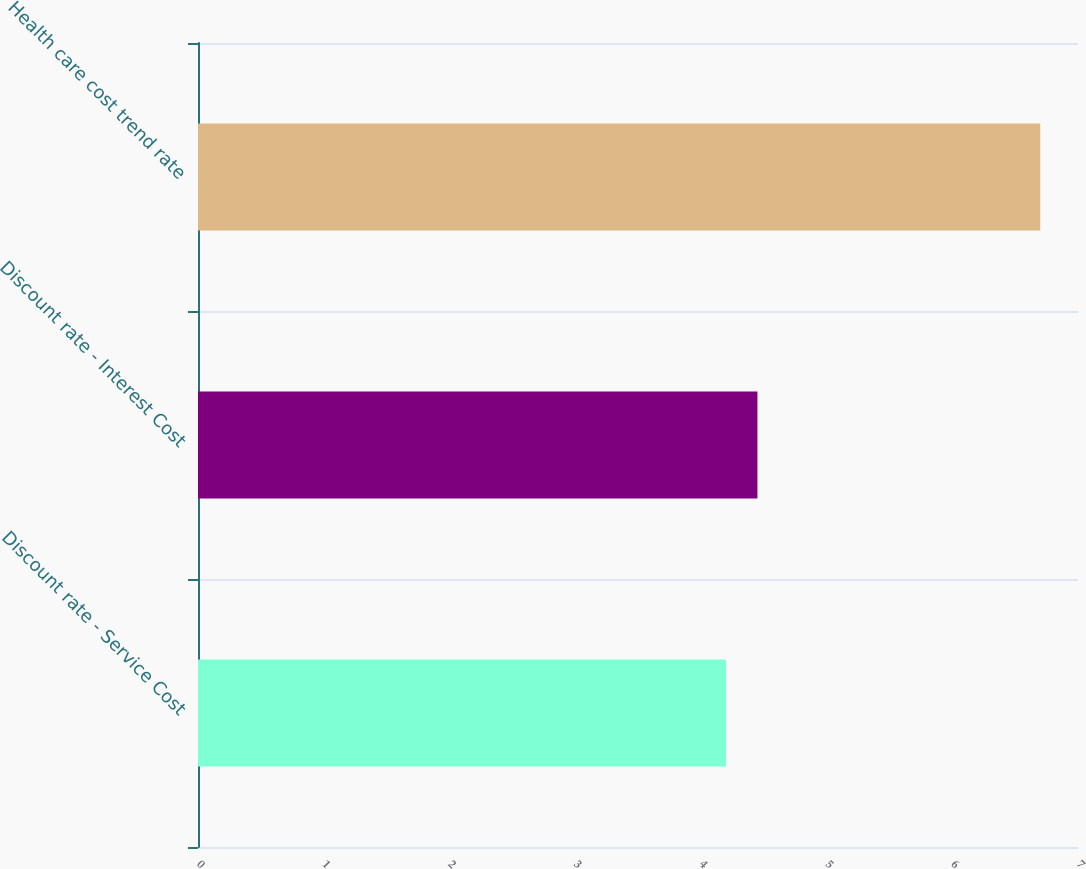Convert chart to OTSL. <chart><loc_0><loc_0><loc_500><loc_500><bar_chart><fcel>Discount rate - Service Cost<fcel>Discount rate - Interest Cost<fcel>Health care cost trend rate<nl><fcel>4.2<fcel>4.45<fcel>6.7<nl></chart> 